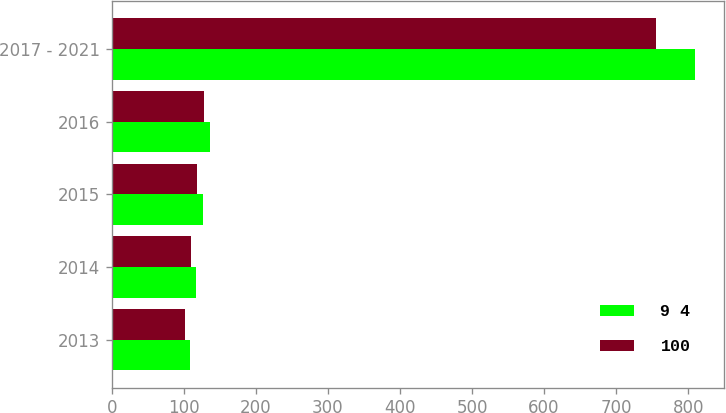<chart> <loc_0><loc_0><loc_500><loc_500><stacked_bar_chart><ecel><fcel>2013<fcel>2014<fcel>2015<fcel>2016<fcel>2017 - 2021<nl><fcel>9 4<fcel>108<fcel>117<fcel>126<fcel>136<fcel>809<nl><fcel>100<fcel>102<fcel>110<fcel>119<fcel>128<fcel>755<nl></chart> 